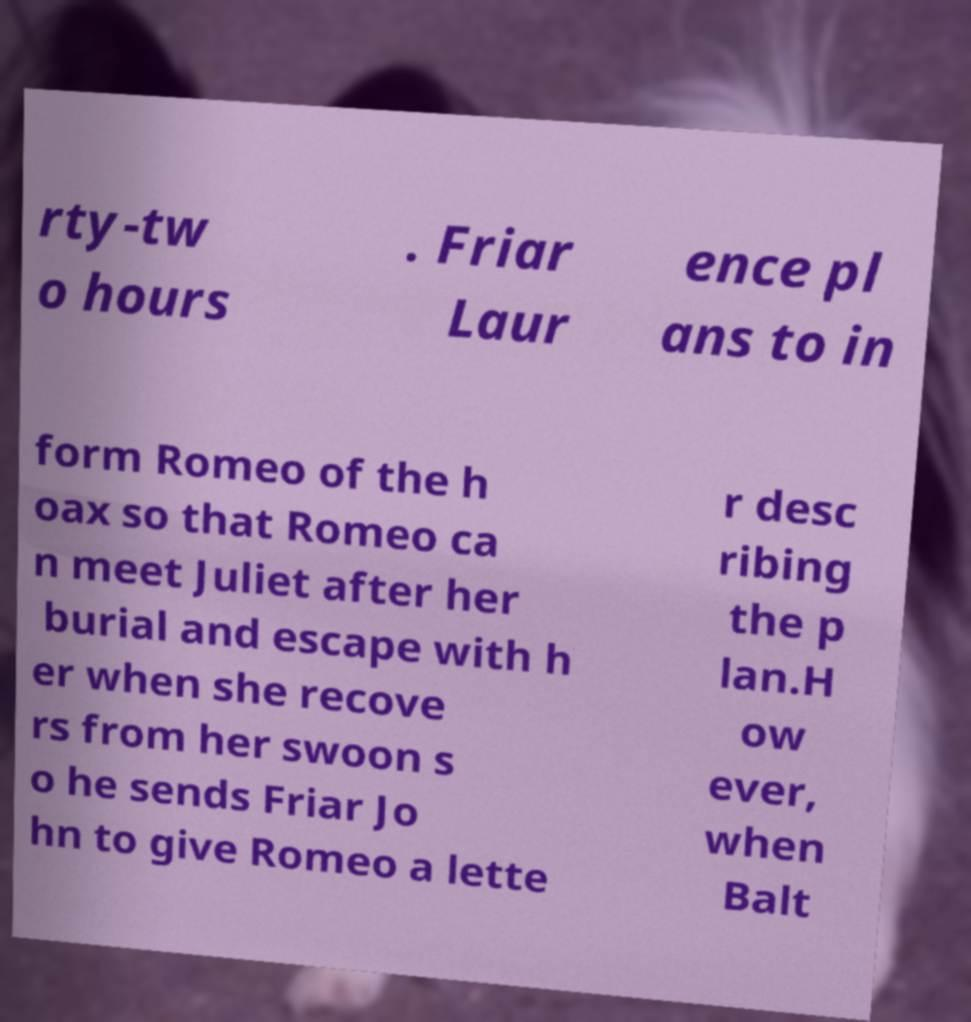There's text embedded in this image that I need extracted. Can you transcribe it verbatim? rty-tw o hours . Friar Laur ence pl ans to in form Romeo of the h oax so that Romeo ca n meet Juliet after her burial and escape with h er when she recove rs from her swoon s o he sends Friar Jo hn to give Romeo a lette r desc ribing the p lan.H ow ever, when Balt 